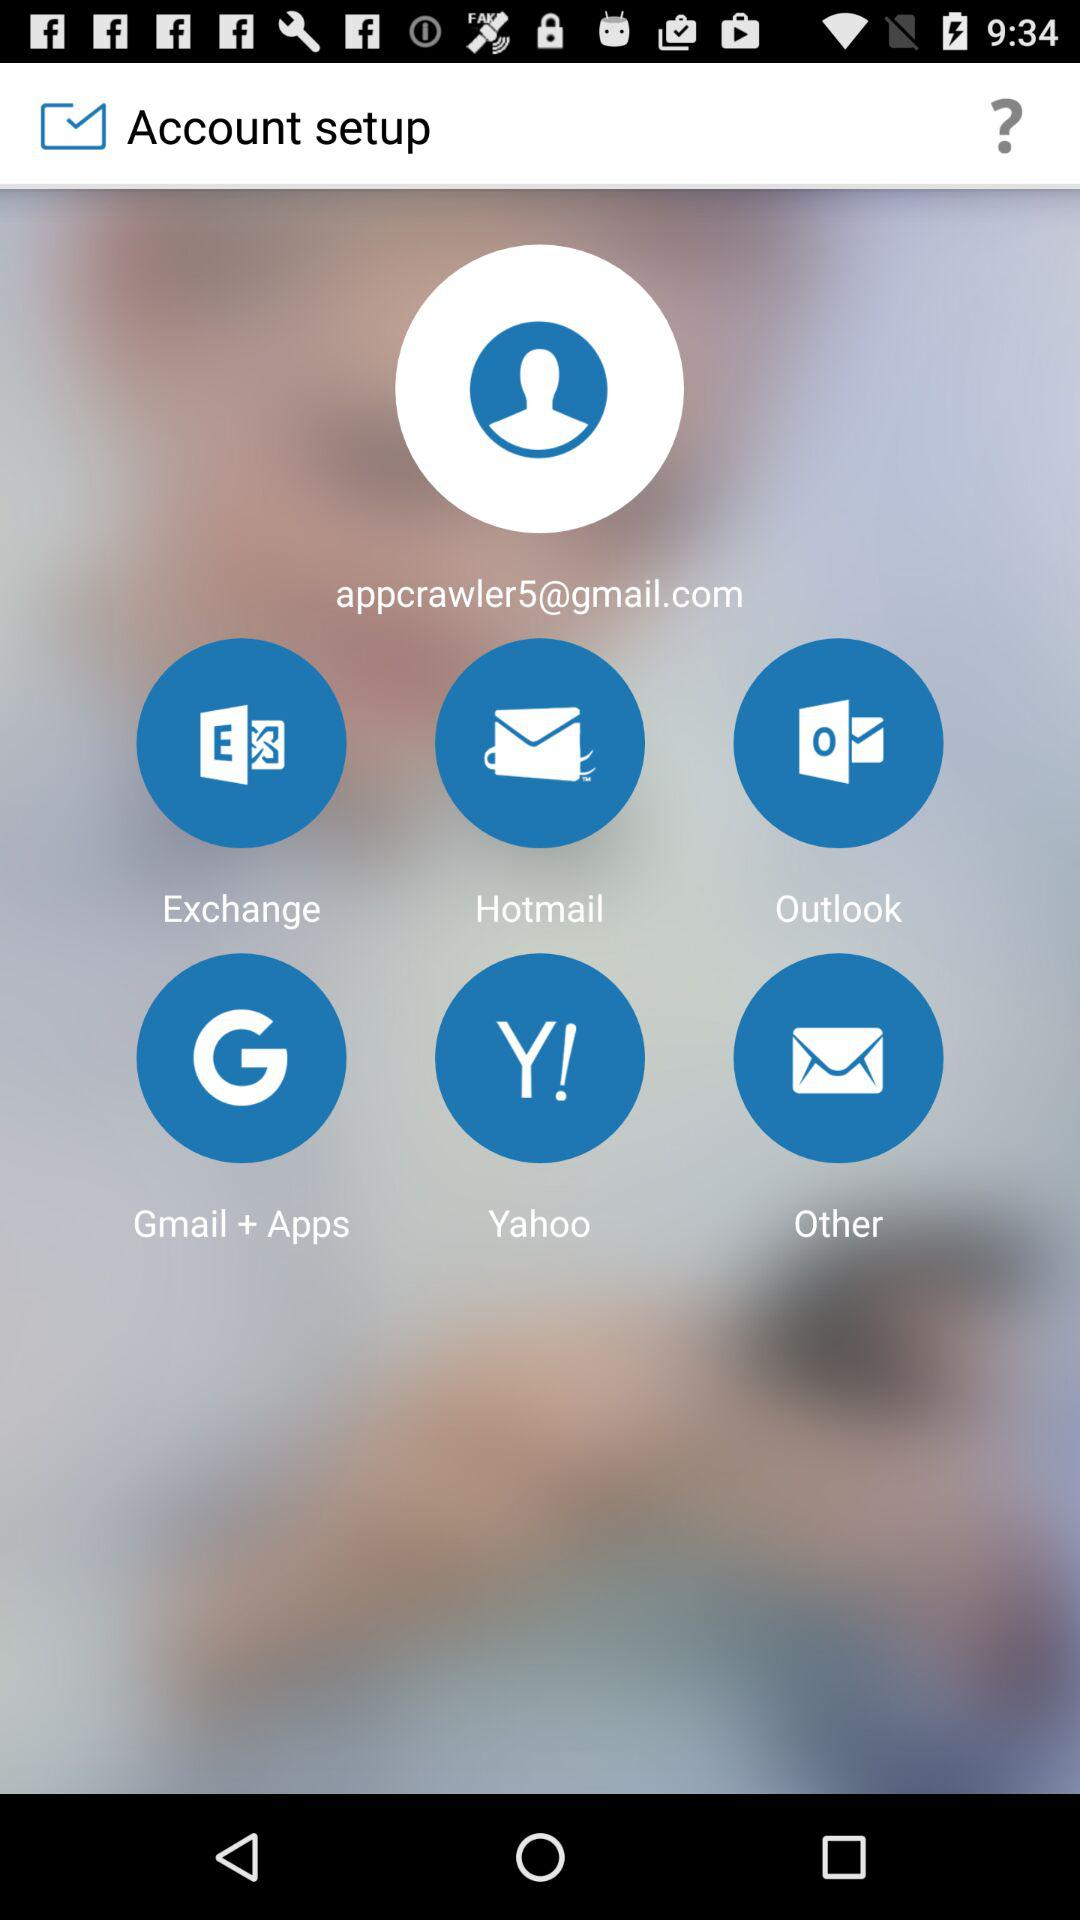What is the email address? The email address is appcrawler5@gmail.com. 